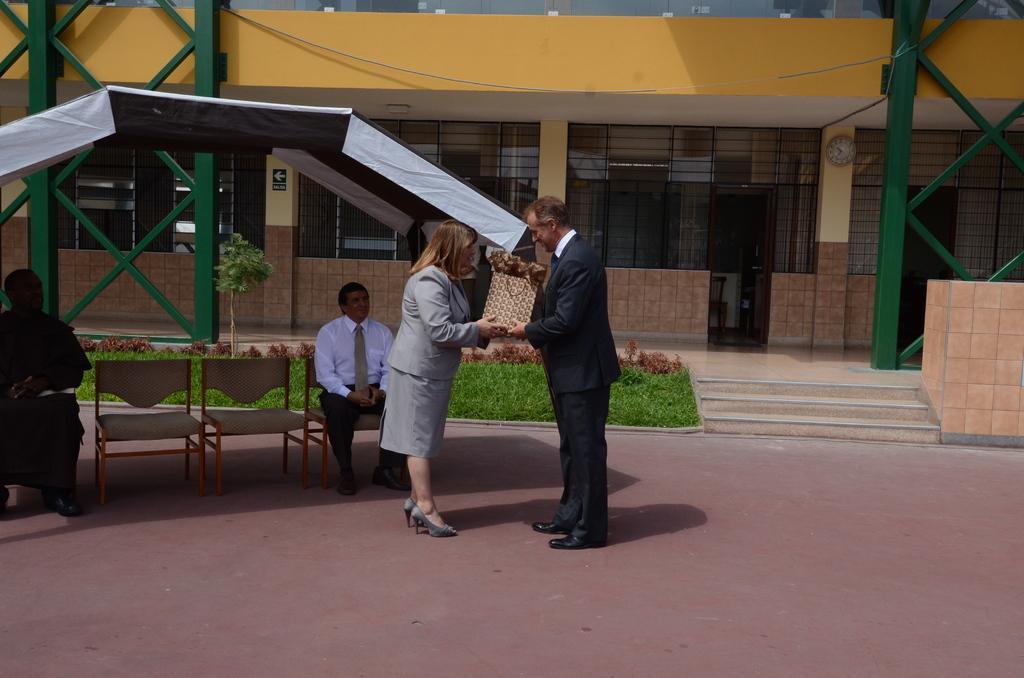Could you give a brief overview of what you see in this image? This image is taken outdoors. At the bottom of the image there is a floor. In the background there is a building with walls, windows and doors. There are a few iron bars and there is a plant. There is a ground with grass on it. On the left side of the image there is a tent. Two men are sitting on the chairs and there are two empty chairs. In the middle of the image a man and a woman are standing on the floor and they are holding a cover in their hands. 